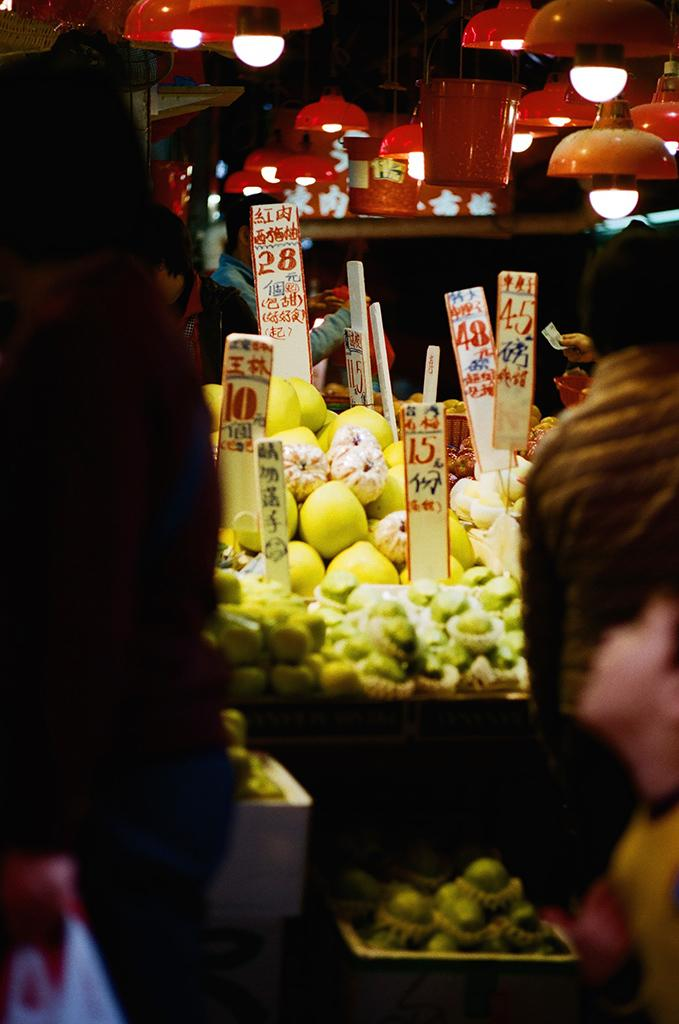How many people are in the image? There are persons in the image, but the exact number is not specified. What can be seen in the image besides the persons? Lights, fruits in a basket, and boards between the fruits are visible in the image. What type of cloth is draped over the chair in the image? There is no chair or cloth present in the image. Is the carpenter working on the boards in the image? There is no carpenter or indication of any work being done on the boards in the image. 